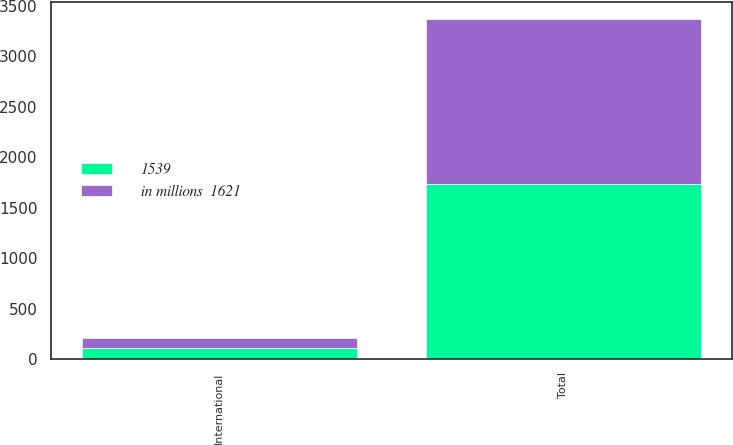Convert chart to OTSL. <chart><loc_0><loc_0><loc_500><loc_500><stacked_bar_chart><ecel><fcel>International<fcel>Total<nl><fcel>1539<fcel>111<fcel>1732<nl><fcel>in millions  1621<fcel>95<fcel>1634<nl></chart> 